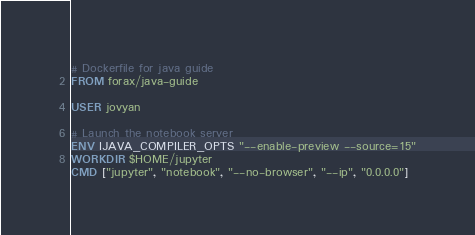<code> <loc_0><loc_0><loc_500><loc_500><_Dockerfile_># Dockerfile for java guide
FROM forax/java-guide

USER jovyan

# Launch the notebook server
ENV IJAVA_COMPILER_OPTS "--enable-preview --source=15"
WORKDIR $HOME/jupyter
CMD ["jupyter", "notebook", "--no-browser", "--ip", "0.0.0.0"]

</code> 